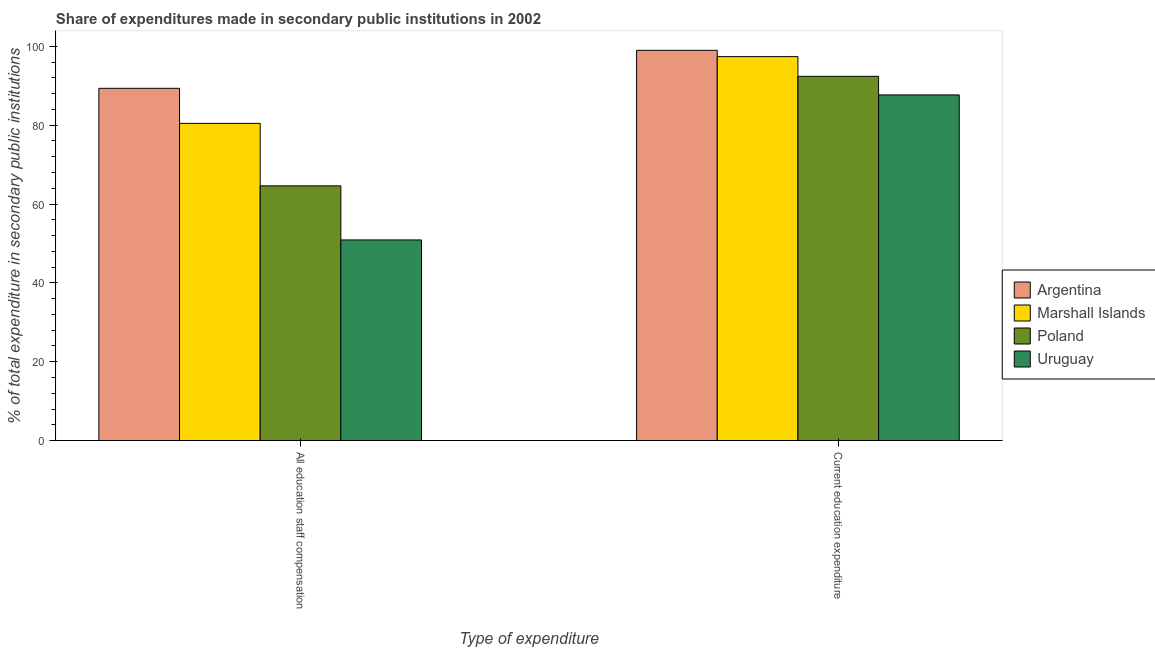Are the number of bars on each tick of the X-axis equal?
Offer a very short reply. Yes. How many bars are there on the 1st tick from the right?
Offer a very short reply. 4. What is the label of the 1st group of bars from the left?
Your answer should be very brief. All education staff compensation. What is the expenditure in staff compensation in Uruguay?
Offer a very short reply. 50.89. Across all countries, what is the maximum expenditure in staff compensation?
Provide a short and direct response. 89.35. Across all countries, what is the minimum expenditure in staff compensation?
Ensure brevity in your answer.  50.89. In which country was the expenditure in education minimum?
Provide a succinct answer. Uruguay. What is the total expenditure in education in the graph?
Give a very brief answer. 376.42. What is the difference between the expenditure in staff compensation in Argentina and that in Marshall Islands?
Make the answer very short. 8.89. What is the difference between the expenditure in education in Uruguay and the expenditure in staff compensation in Poland?
Your answer should be very brief. 23.06. What is the average expenditure in education per country?
Your response must be concise. 94.1. What is the difference between the expenditure in education and expenditure in staff compensation in Uruguay?
Provide a short and direct response. 36.78. What is the ratio of the expenditure in education in Argentina to that in Poland?
Offer a terse response. 1.07. What does the 2nd bar from the left in All education staff compensation represents?
Make the answer very short. Marshall Islands. What does the 3rd bar from the right in All education staff compensation represents?
Provide a short and direct response. Marshall Islands. How many bars are there?
Your answer should be compact. 8. What is the difference between two consecutive major ticks on the Y-axis?
Offer a very short reply. 20. Does the graph contain any zero values?
Offer a very short reply. No. Where does the legend appear in the graph?
Offer a terse response. Center right. How many legend labels are there?
Give a very brief answer. 4. How are the legend labels stacked?
Give a very brief answer. Vertical. What is the title of the graph?
Provide a succinct answer. Share of expenditures made in secondary public institutions in 2002. What is the label or title of the X-axis?
Offer a terse response. Type of expenditure. What is the label or title of the Y-axis?
Your answer should be very brief. % of total expenditure in secondary public institutions. What is the % of total expenditure in secondary public institutions in Argentina in All education staff compensation?
Make the answer very short. 89.35. What is the % of total expenditure in secondary public institutions of Marshall Islands in All education staff compensation?
Make the answer very short. 80.45. What is the % of total expenditure in secondary public institutions in Poland in All education staff compensation?
Make the answer very short. 64.61. What is the % of total expenditure in secondary public institutions in Uruguay in All education staff compensation?
Keep it short and to the point. 50.89. What is the % of total expenditure in secondary public institutions of Argentina in Current education expenditure?
Give a very brief answer. 98.98. What is the % of total expenditure in secondary public institutions of Marshall Islands in Current education expenditure?
Offer a very short reply. 97.38. What is the % of total expenditure in secondary public institutions of Poland in Current education expenditure?
Your response must be concise. 92.39. What is the % of total expenditure in secondary public institutions in Uruguay in Current education expenditure?
Offer a very short reply. 87.67. Across all Type of expenditure, what is the maximum % of total expenditure in secondary public institutions in Argentina?
Offer a terse response. 98.98. Across all Type of expenditure, what is the maximum % of total expenditure in secondary public institutions of Marshall Islands?
Provide a succinct answer. 97.38. Across all Type of expenditure, what is the maximum % of total expenditure in secondary public institutions of Poland?
Give a very brief answer. 92.39. Across all Type of expenditure, what is the maximum % of total expenditure in secondary public institutions in Uruguay?
Offer a very short reply. 87.67. Across all Type of expenditure, what is the minimum % of total expenditure in secondary public institutions in Argentina?
Provide a short and direct response. 89.35. Across all Type of expenditure, what is the minimum % of total expenditure in secondary public institutions of Marshall Islands?
Keep it short and to the point. 80.45. Across all Type of expenditure, what is the minimum % of total expenditure in secondary public institutions of Poland?
Give a very brief answer. 64.61. Across all Type of expenditure, what is the minimum % of total expenditure in secondary public institutions of Uruguay?
Provide a succinct answer. 50.89. What is the total % of total expenditure in secondary public institutions in Argentina in the graph?
Provide a succinct answer. 188.32. What is the total % of total expenditure in secondary public institutions of Marshall Islands in the graph?
Provide a succinct answer. 177.83. What is the total % of total expenditure in secondary public institutions in Poland in the graph?
Offer a very short reply. 156.99. What is the total % of total expenditure in secondary public institutions of Uruguay in the graph?
Ensure brevity in your answer.  138.56. What is the difference between the % of total expenditure in secondary public institutions of Argentina in All education staff compensation and that in Current education expenditure?
Provide a short and direct response. -9.63. What is the difference between the % of total expenditure in secondary public institutions in Marshall Islands in All education staff compensation and that in Current education expenditure?
Provide a short and direct response. -16.93. What is the difference between the % of total expenditure in secondary public institutions of Poland in All education staff compensation and that in Current education expenditure?
Your answer should be compact. -27.78. What is the difference between the % of total expenditure in secondary public institutions of Uruguay in All education staff compensation and that in Current education expenditure?
Provide a short and direct response. -36.78. What is the difference between the % of total expenditure in secondary public institutions of Argentina in All education staff compensation and the % of total expenditure in secondary public institutions of Marshall Islands in Current education expenditure?
Your answer should be compact. -8.04. What is the difference between the % of total expenditure in secondary public institutions of Argentina in All education staff compensation and the % of total expenditure in secondary public institutions of Poland in Current education expenditure?
Offer a terse response. -3.04. What is the difference between the % of total expenditure in secondary public institutions of Argentina in All education staff compensation and the % of total expenditure in secondary public institutions of Uruguay in Current education expenditure?
Your answer should be very brief. 1.67. What is the difference between the % of total expenditure in secondary public institutions of Marshall Islands in All education staff compensation and the % of total expenditure in secondary public institutions of Poland in Current education expenditure?
Give a very brief answer. -11.93. What is the difference between the % of total expenditure in secondary public institutions of Marshall Islands in All education staff compensation and the % of total expenditure in secondary public institutions of Uruguay in Current education expenditure?
Offer a terse response. -7.22. What is the difference between the % of total expenditure in secondary public institutions of Poland in All education staff compensation and the % of total expenditure in secondary public institutions of Uruguay in Current education expenditure?
Your answer should be compact. -23.06. What is the average % of total expenditure in secondary public institutions of Argentina per Type of expenditure?
Offer a terse response. 94.16. What is the average % of total expenditure in secondary public institutions in Marshall Islands per Type of expenditure?
Your response must be concise. 88.92. What is the average % of total expenditure in secondary public institutions of Poland per Type of expenditure?
Your answer should be very brief. 78.5. What is the average % of total expenditure in secondary public institutions in Uruguay per Type of expenditure?
Your response must be concise. 69.28. What is the difference between the % of total expenditure in secondary public institutions of Argentina and % of total expenditure in secondary public institutions of Marshall Islands in All education staff compensation?
Give a very brief answer. 8.89. What is the difference between the % of total expenditure in secondary public institutions of Argentina and % of total expenditure in secondary public institutions of Poland in All education staff compensation?
Keep it short and to the point. 24.74. What is the difference between the % of total expenditure in secondary public institutions in Argentina and % of total expenditure in secondary public institutions in Uruguay in All education staff compensation?
Your answer should be compact. 38.45. What is the difference between the % of total expenditure in secondary public institutions in Marshall Islands and % of total expenditure in secondary public institutions in Poland in All education staff compensation?
Your response must be concise. 15.84. What is the difference between the % of total expenditure in secondary public institutions in Marshall Islands and % of total expenditure in secondary public institutions in Uruguay in All education staff compensation?
Your response must be concise. 29.56. What is the difference between the % of total expenditure in secondary public institutions of Poland and % of total expenditure in secondary public institutions of Uruguay in All education staff compensation?
Your answer should be very brief. 13.72. What is the difference between the % of total expenditure in secondary public institutions in Argentina and % of total expenditure in secondary public institutions in Marshall Islands in Current education expenditure?
Your answer should be very brief. 1.6. What is the difference between the % of total expenditure in secondary public institutions in Argentina and % of total expenditure in secondary public institutions in Poland in Current education expenditure?
Your answer should be compact. 6.59. What is the difference between the % of total expenditure in secondary public institutions of Argentina and % of total expenditure in secondary public institutions of Uruguay in Current education expenditure?
Your answer should be compact. 11.31. What is the difference between the % of total expenditure in secondary public institutions of Marshall Islands and % of total expenditure in secondary public institutions of Poland in Current education expenditure?
Your answer should be very brief. 5. What is the difference between the % of total expenditure in secondary public institutions in Marshall Islands and % of total expenditure in secondary public institutions in Uruguay in Current education expenditure?
Give a very brief answer. 9.71. What is the difference between the % of total expenditure in secondary public institutions of Poland and % of total expenditure in secondary public institutions of Uruguay in Current education expenditure?
Offer a terse response. 4.72. What is the ratio of the % of total expenditure in secondary public institutions in Argentina in All education staff compensation to that in Current education expenditure?
Make the answer very short. 0.9. What is the ratio of the % of total expenditure in secondary public institutions in Marshall Islands in All education staff compensation to that in Current education expenditure?
Your response must be concise. 0.83. What is the ratio of the % of total expenditure in secondary public institutions in Poland in All education staff compensation to that in Current education expenditure?
Give a very brief answer. 0.7. What is the ratio of the % of total expenditure in secondary public institutions in Uruguay in All education staff compensation to that in Current education expenditure?
Your response must be concise. 0.58. What is the difference between the highest and the second highest % of total expenditure in secondary public institutions in Argentina?
Offer a very short reply. 9.63. What is the difference between the highest and the second highest % of total expenditure in secondary public institutions of Marshall Islands?
Make the answer very short. 16.93. What is the difference between the highest and the second highest % of total expenditure in secondary public institutions in Poland?
Give a very brief answer. 27.78. What is the difference between the highest and the second highest % of total expenditure in secondary public institutions of Uruguay?
Give a very brief answer. 36.78. What is the difference between the highest and the lowest % of total expenditure in secondary public institutions in Argentina?
Provide a short and direct response. 9.63. What is the difference between the highest and the lowest % of total expenditure in secondary public institutions of Marshall Islands?
Provide a short and direct response. 16.93. What is the difference between the highest and the lowest % of total expenditure in secondary public institutions in Poland?
Ensure brevity in your answer.  27.78. What is the difference between the highest and the lowest % of total expenditure in secondary public institutions in Uruguay?
Offer a terse response. 36.78. 